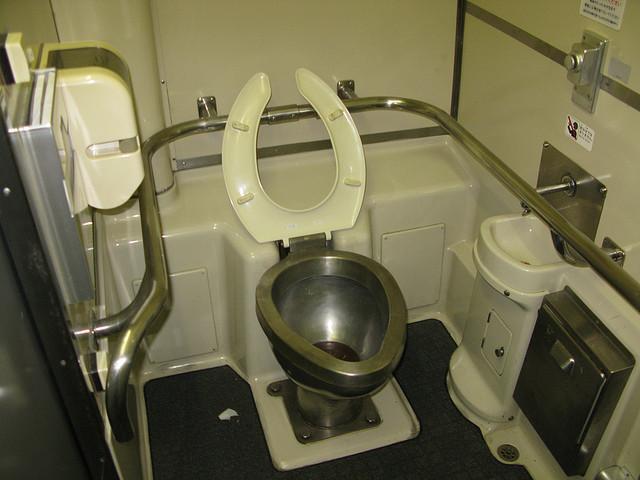How many dogs are wearing a chain collar?
Give a very brief answer. 0. 